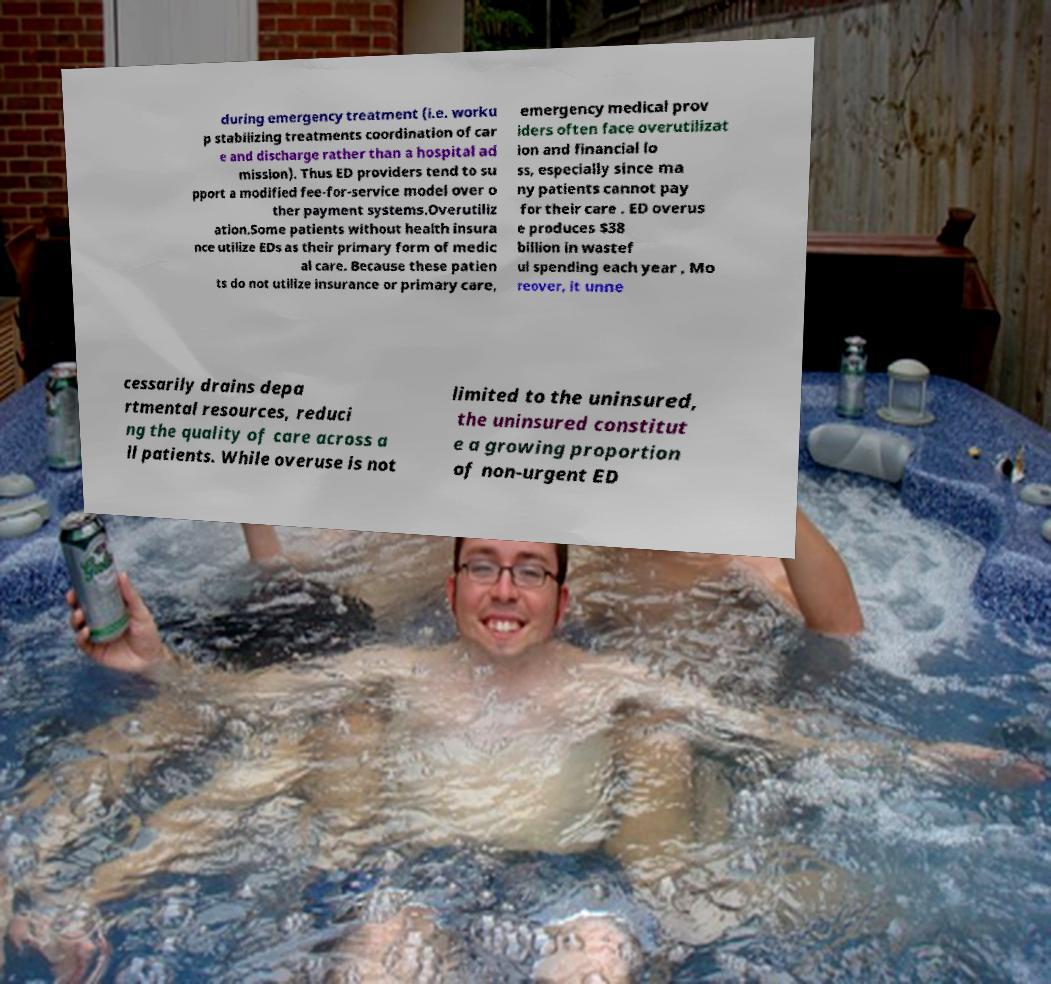There's text embedded in this image that I need extracted. Can you transcribe it verbatim? during emergency treatment (i.e. worku p stabilizing treatments coordination of car e and discharge rather than a hospital ad mission). Thus ED providers tend to su pport a modified fee-for-service model over o ther payment systems.Overutiliz ation.Some patients without health insura nce utilize EDs as their primary form of medic al care. Because these patien ts do not utilize insurance or primary care, emergency medical prov iders often face overutilizat ion and financial lo ss, especially since ma ny patients cannot pay for their care . ED overus e produces $38 billion in wastef ul spending each year , Mo reover, it unne cessarily drains depa rtmental resources, reduci ng the quality of care across a ll patients. While overuse is not limited to the uninsured, the uninsured constitut e a growing proportion of non-urgent ED 